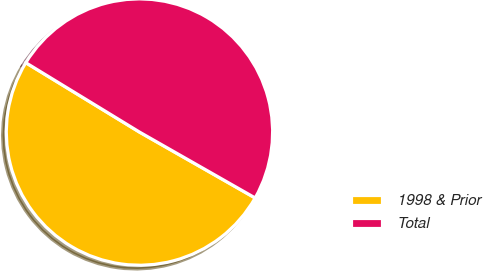Convert chart. <chart><loc_0><loc_0><loc_500><loc_500><pie_chart><fcel>1998 & Prior<fcel>Total<nl><fcel>50.48%<fcel>49.52%<nl></chart> 